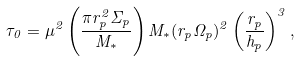<formula> <loc_0><loc_0><loc_500><loc_500>\tau _ { 0 } = \mu ^ { 2 } \left ( \frac { \pi r _ { p } ^ { 2 } \Sigma _ { p } } { M _ { * } } \right ) M _ { * } ( r _ { p } \Omega _ { p } ) ^ { 2 } \left ( \frac { r _ { p } } { h _ { p } } \right ) ^ { 3 } ,</formula> 